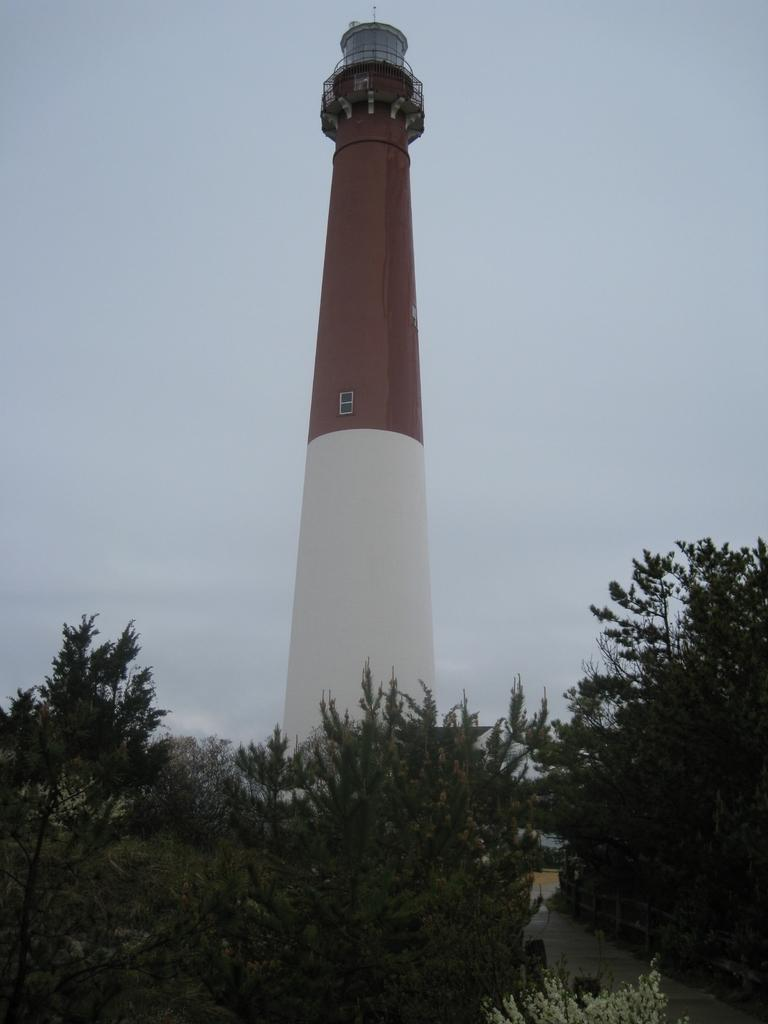What is the main structure in the center of the image? There is a tower in the center of the image. What type of vegetation is present at the bottom of the image? There are trees at the bottom of the image. What pathway can be seen in the image? There is a walkway in the image. What is visible at the top of the image? The sky is visible at the top of the image. How many apples are hanging from the trees in the image? There are no apples visible in the image; only trees are present at the bottom of the image. What type of coach can be seen driving along the walkway in the image? There is no coach present in the image; only the tower, trees, walkway, and sky are visible. 